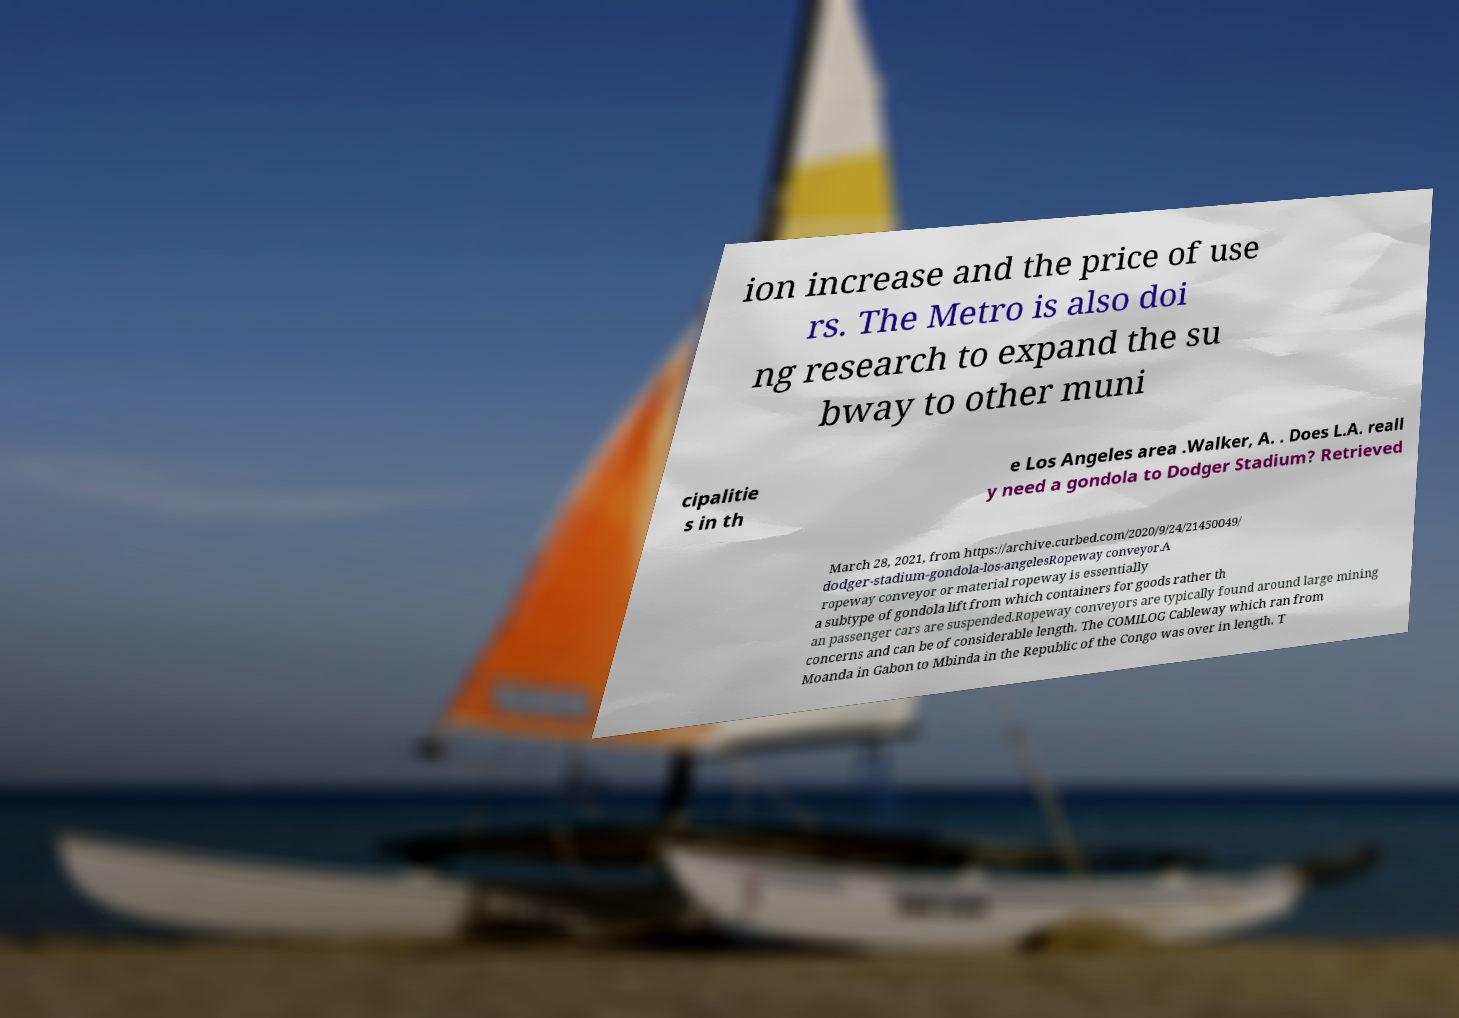I need the written content from this picture converted into text. Can you do that? ion increase and the price of use rs. The Metro is also doi ng research to expand the su bway to other muni cipalitie s in th e Los Angeles area .Walker, A. . Does L.A. reall y need a gondola to Dodger Stadium? Retrieved March 28, 2021, from https://archive.curbed.com/2020/9/24/21450049/ dodger-stadium-gondola-los-angelesRopeway conveyor.A ropeway conveyor or material ropeway is essentially a subtype of gondola lift from which containers for goods rather th an passenger cars are suspended.Ropeway conveyors are typically found around large mining concerns and can be of considerable length. The COMILOG Cableway which ran from Moanda in Gabon to Mbinda in the Republic of the Congo was over in length. T 